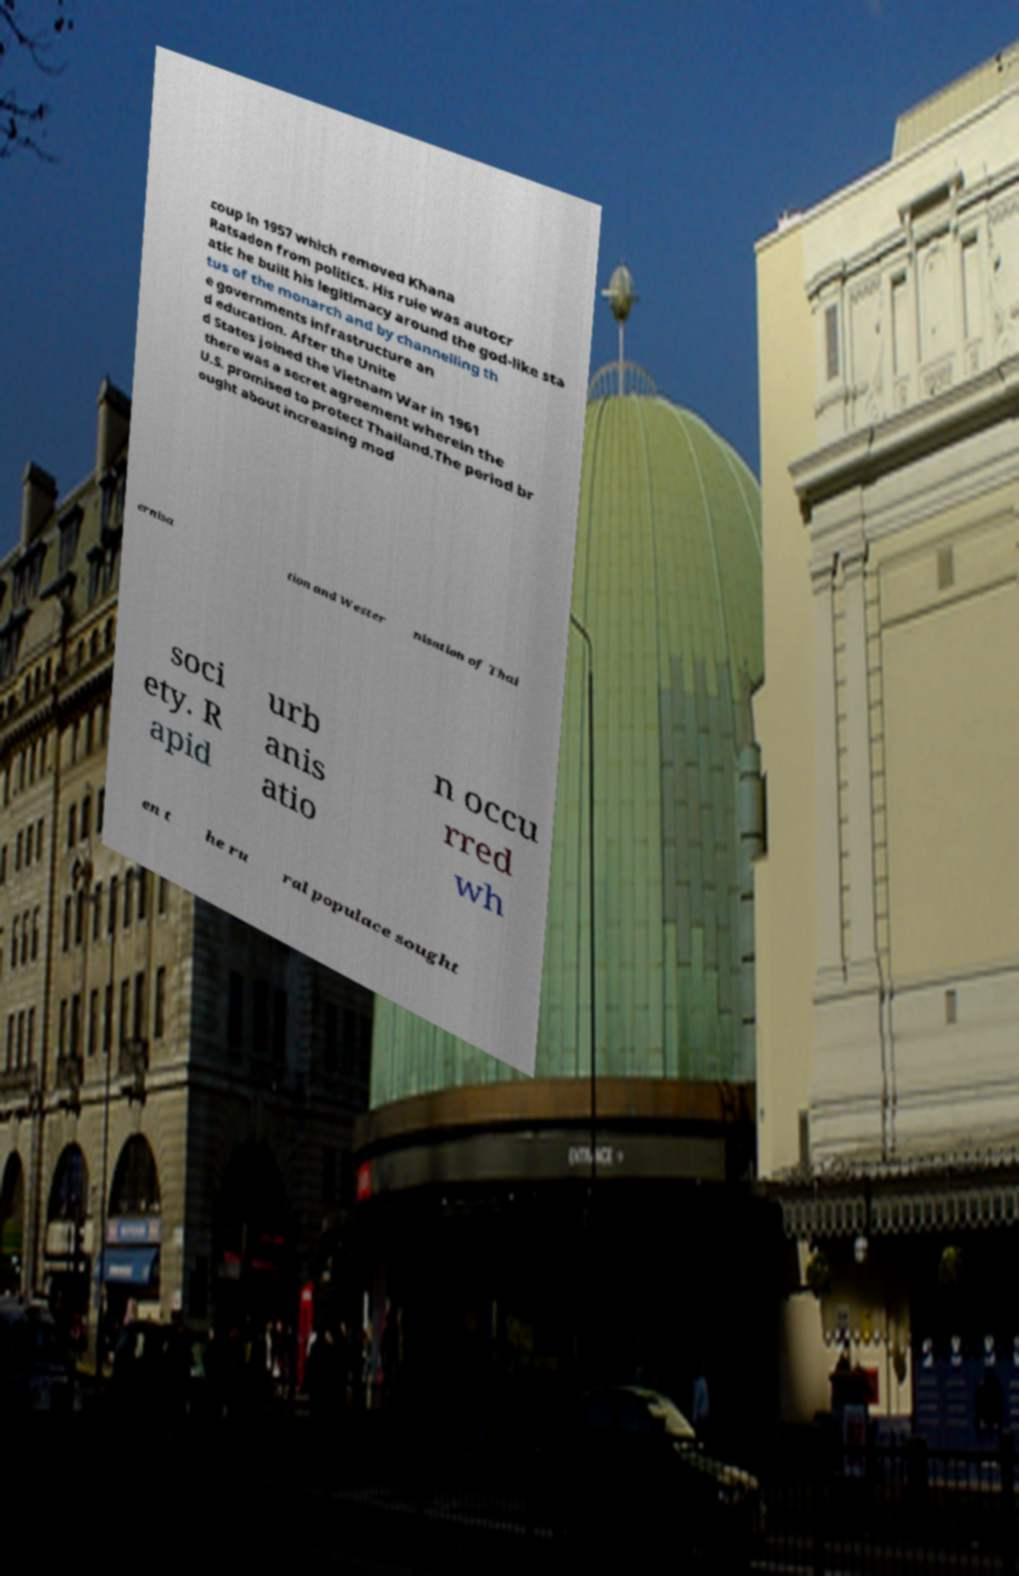For documentation purposes, I need the text within this image transcribed. Could you provide that? coup in 1957 which removed Khana Ratsadon from politics. His rule was autocr atic he built his legitimacy around the god-like sta tus of the monarch and by channelling th e governments infrastructure an d education. After the Unite d States joined the Vietnam War in 1961 there was a secret agreement wherein the U.S. promised to protect Thailand.The period br ought about increasing mod ernisa tion and Wester nisation of Thai soci ety. R apid urb anis atio n occu rred wh en t he ru ral populace sought 